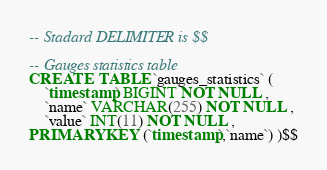<code> <loc_0><loc_0><loc_500><loc_500><_SQL_>-- Stadard DELIMITER is $$

-- Gauges statistics table
CREATE  TABLE `gauges_statistics` (
    `timestamp` BIGINT NOT NULL ,
    `name` VARCHAR(255) NOT NULL ,
    `value` INT(11) NOT NULL ,
PRIMARY KEY (`timestamp`,`name`) )$$
</code> 